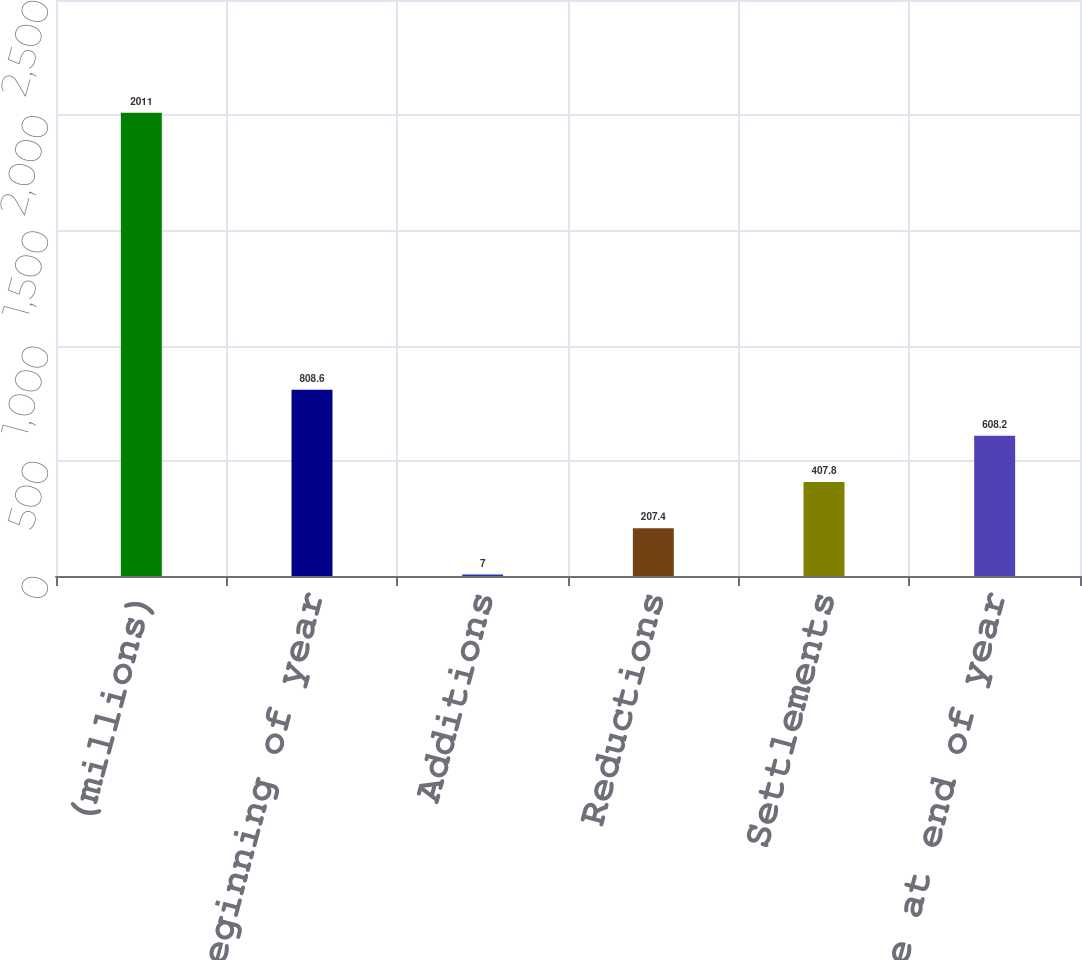Convert chart to OTSL. <chart><loc_0><loc_0><loc_500><loc_500><bar_chart><fcel>(millions)<fcel>Balance at beginning of year<fcel>Additions<fcel>Reductions<fcel>Settlements<fcel>Balance at end of year<nl><fcel>2011<fcel>808.6<fcel>7<fcel>207.4<fcel>407.8<fcel>608.2<nl></chart> 